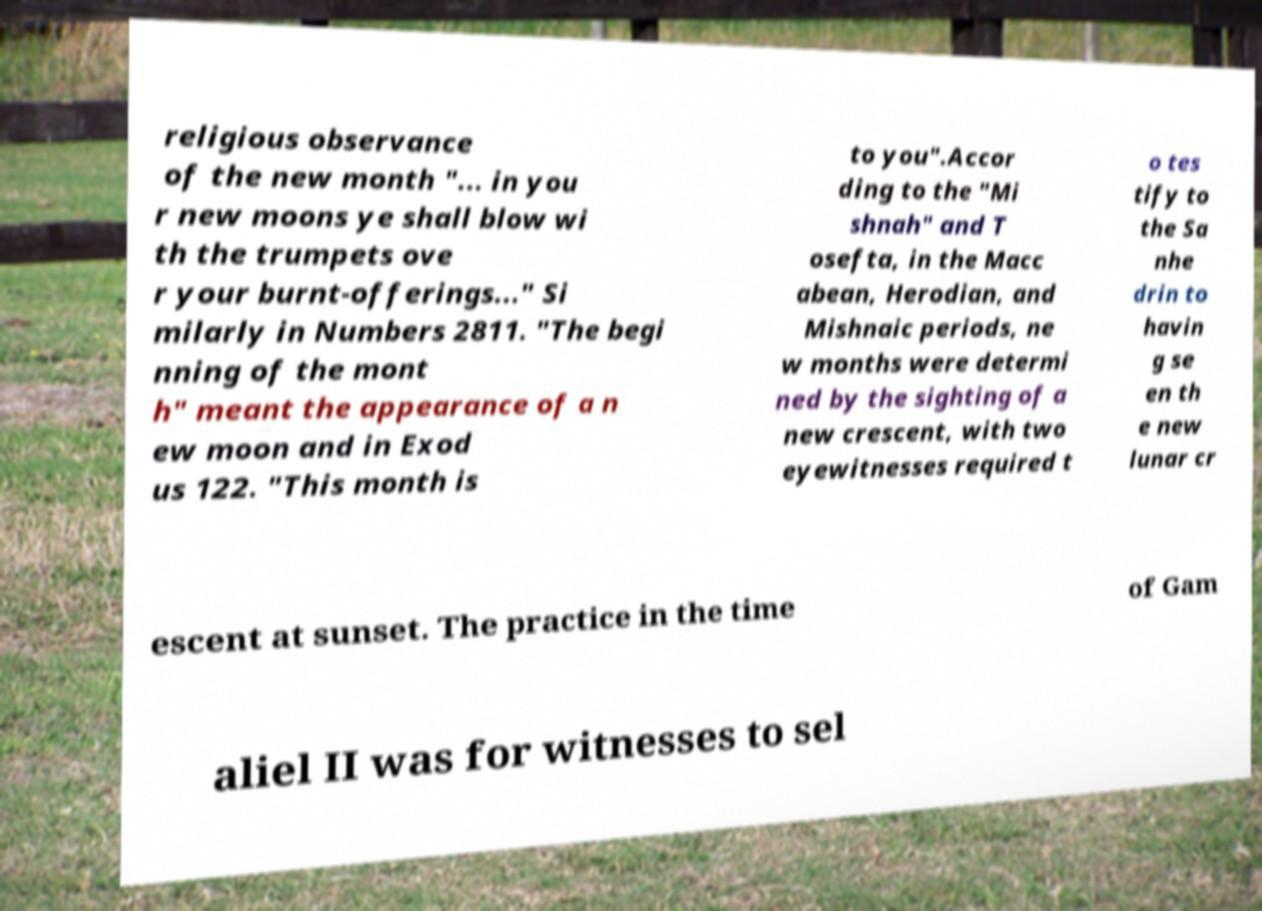There's text embedded in this image that I need extracted. Can you transcribe it verbatim? religious observance of the new month "... in you r new moons ye shall blow wi th the trumpets ove r your burnt-offerings..." Si milarly in Numbers 2811. "The begi nning of the mont h" meant the appearance of a n ew moon and in Exod us 122. "This month is to you".Accor ding to the "Mi shnah" and T osefta, in the Macc abean, Herodian, and Mishnaic periods, ne w months were determi ned by the sighting of a new crescent, with two eyewitnesses required t o tes tify to the Sa nhe drin to havin g se en th e new lunar cr escent at sunset. The practice in the time of Gam aliel II was for witnesses to sel 